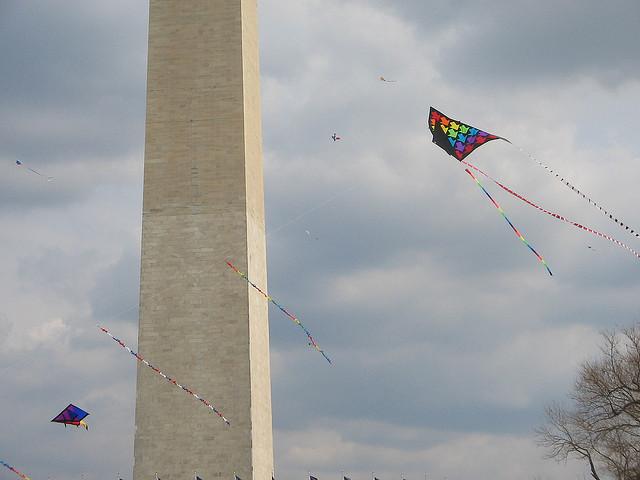What color is the sky?
Short answer required. Blue. What landmark is in this scene?
Write a very short answer. Washington monument. How many colors are on the kite to the right?
Be succinct. 7. 